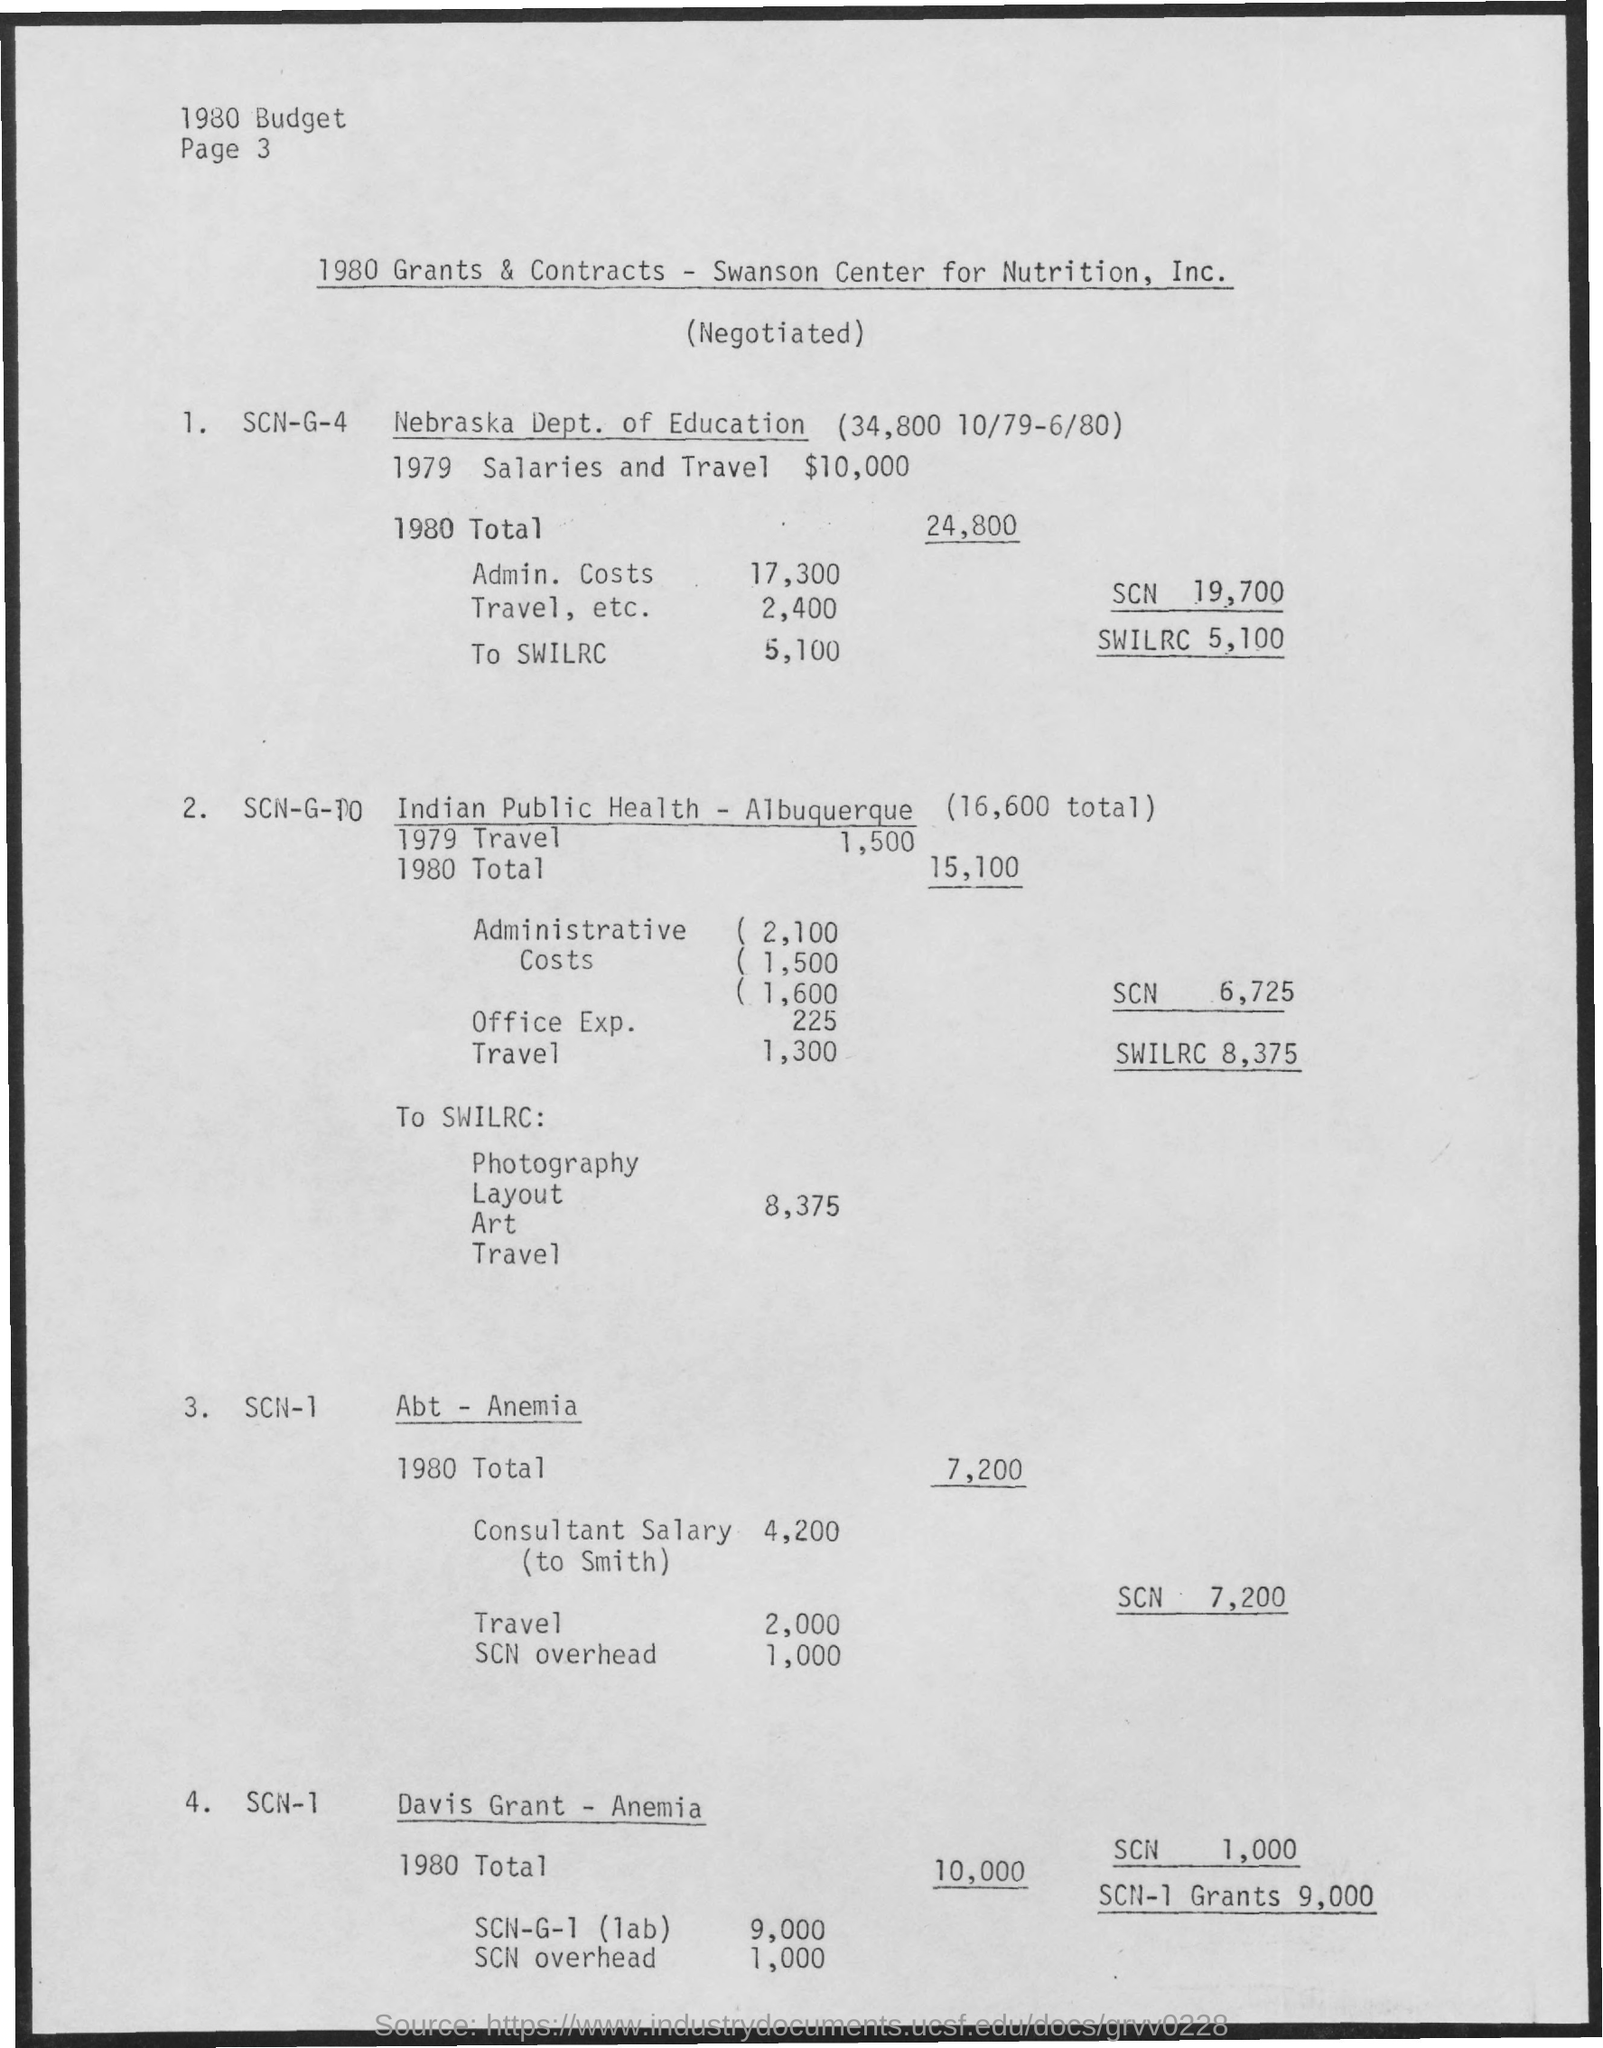What is the 1979 salaries and travel for Nebraska Dept. of Education?
Give a very brief answer. $10,000. What is the 1980 Total for Nebraska Dept. of Education?
Give a very brief answer. 24,800. What is the 1980 Admin. Costs for Nebraska Dept. of Education?
Offer a very short reply. 17,300. What is the 1980 Travel, etc. for Nebraska Dept. of Education?
Ensure brevity in your answer.  2,400. What is the 1980 To Swilrc Nebraska Dept. of Education?
Give a very brief answer. 5,100. What is the 1980 Total for Indian Public Health - Albuquerque?
Your response must be concise. 15,100. What is the 1979 Travel for Indian Public Health - Albuquerque?
Provide a short and direct response. 1,500. What is the 1980 Office Exp. for Indian Public Health - Albuquerque?
Your response must be concise. 225. What is the 1980 Travel for Indian Public Health - Albuquerque?
Your answer should be very brief. 1,300. What is the 1980 to Swilrc for Art for Indian Public Health - Albuquerque?
Ensure brevity in your answer.  8,375. 